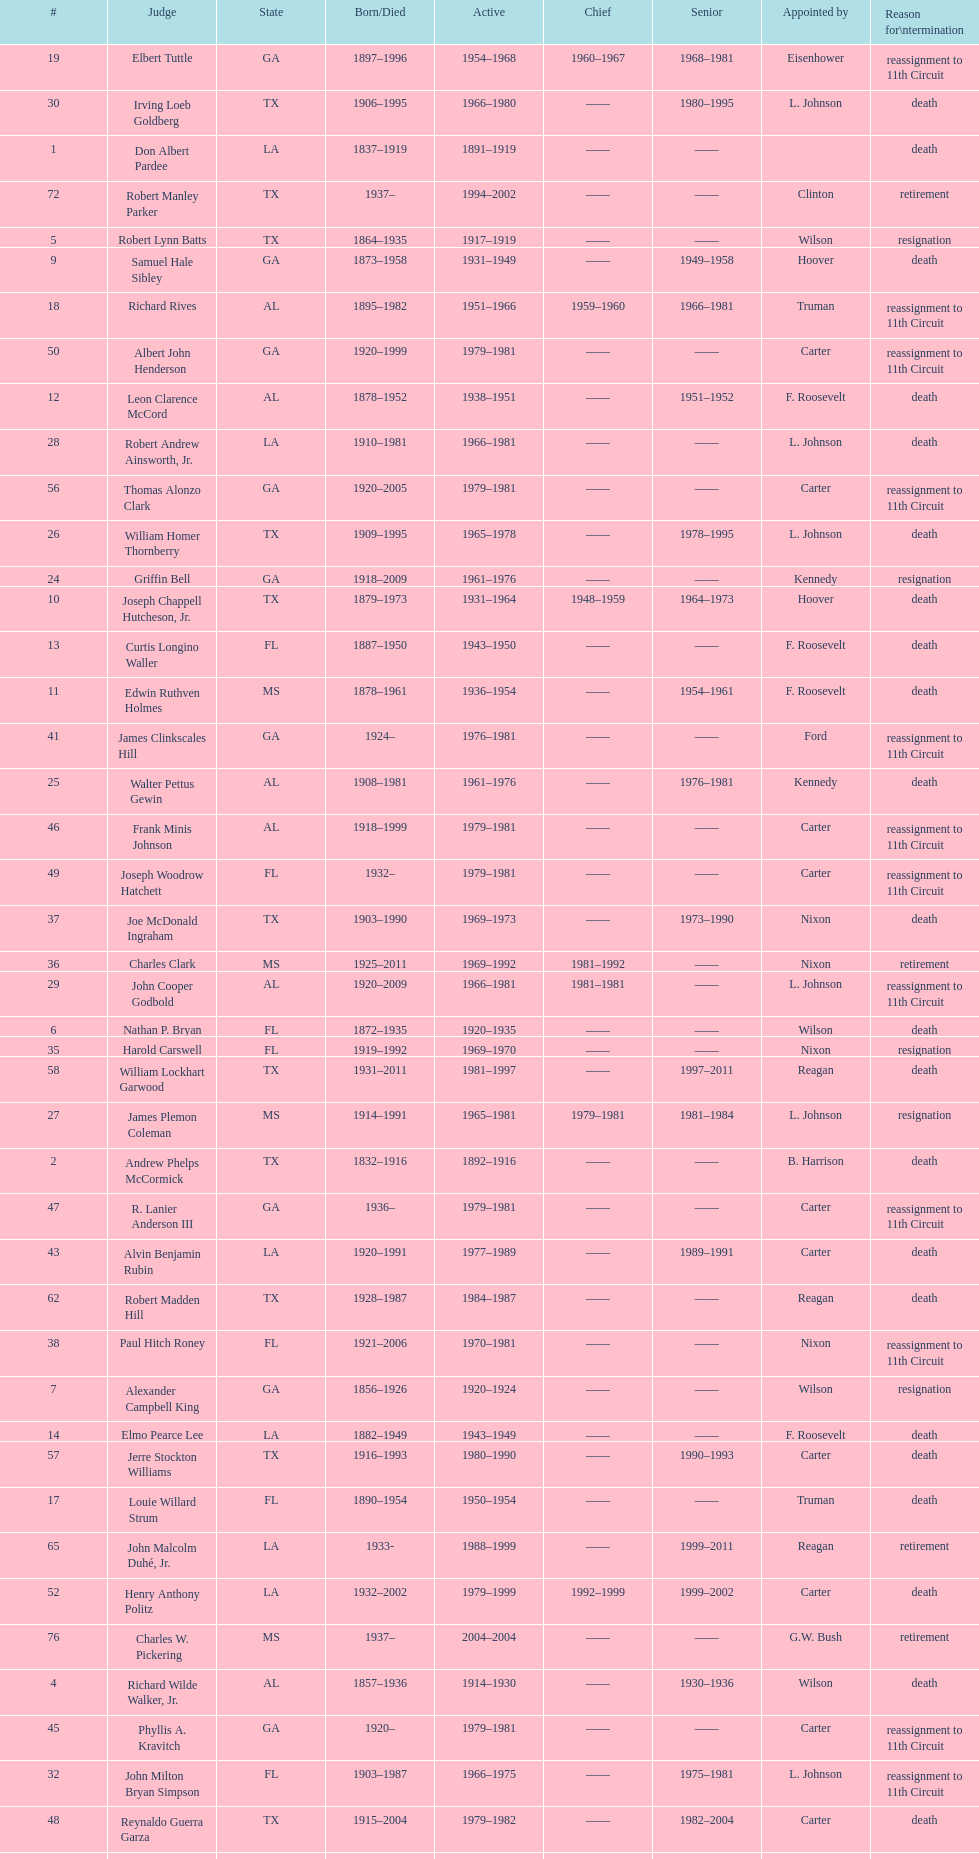How many judges were appointed by president carter? 13. 